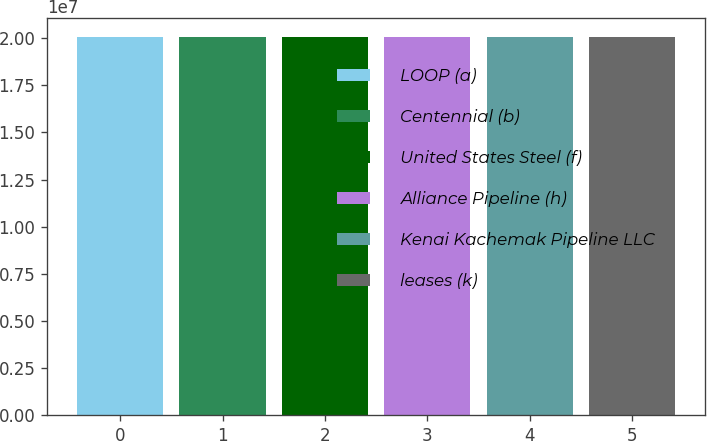<chart> <loc_0><loc_0><loc_500><loc_500><bar_chart><fcel>LOOP (a)<fcel>Centennial (b)<fcel>United States Steel (f)<fcel>Alliance Pipeline (h)<fcel>Kenai Kachemak Pipeline LLC<fcel>leases (k)<nl><fcel>2.006e+07<fcel>2.0072e+07<fcel>2.0054e+07<fcel>2.0056e+07<fcel>2.0058e+07<fcel>2.0052e+07<nl></chart> 